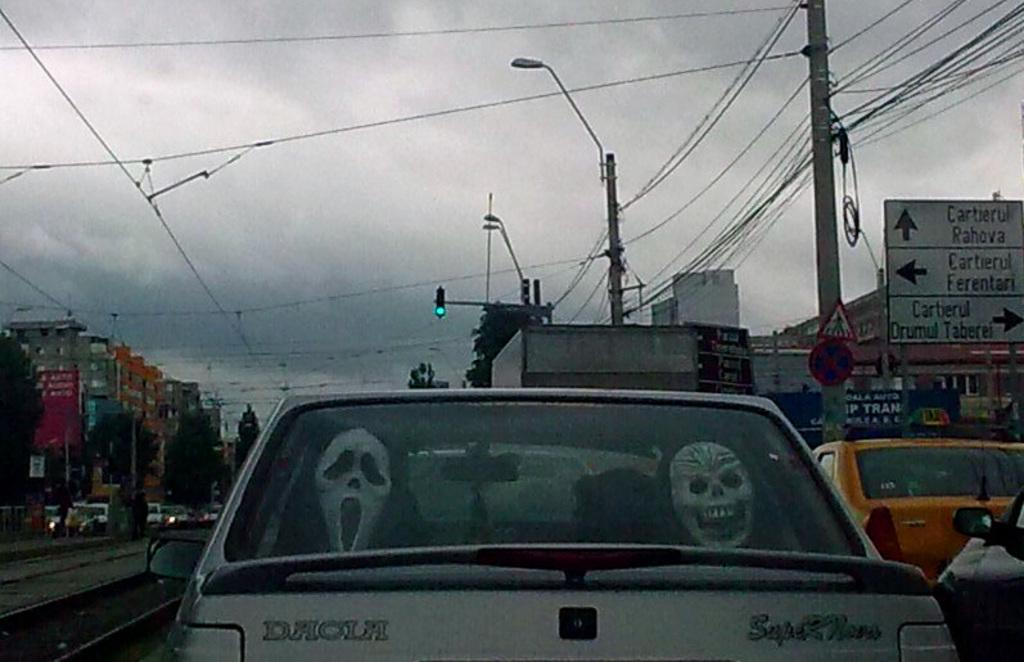<image>
Write a terse but informative summary of the picture. A car with masks in the back is driving on a road that has a sign for Cartierul Pahova. 